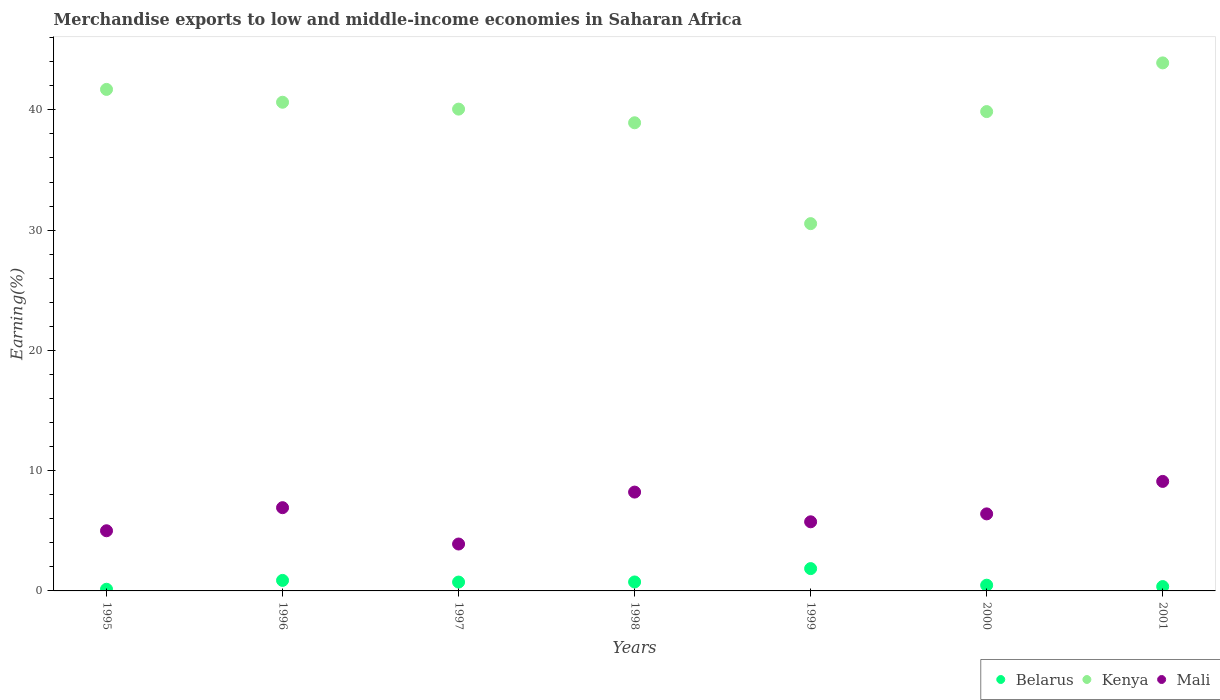How many different coloured dotlines are there?
Provide a short and direct response. 3. Is the number of dotlines equal to the number of legend labels?
Ensure brevity in your answer.  Yes. What is the percentage of amount earned from merchandise exports in Belarus in 1996?
Ensure brevity in your answer.  0.87. Across all years, what is the maximum percentage of amount earned from merchandise exports in Belarus?
Provide a succinct answer. 1.86. Across all years, what is the minimum percentage of amount earned from merchandise exports in Kenya?
Offer a terse response. 30.54. What is the total percentage of amount earned from merchandise exports in Belarus in the graph?
Make the answer very short. 5.19. What is the difference between the percentage of amount earned from merchandise exports in Mali in 1998 and that in 1999?
Make the answer very short. 2.47. What is the difference between the percentage of amount earned from merchandise exports in Mali in 1997 and the percentage of amount earned from merchandise exports in Belarus in 1996?
Offer a very short reply. 3.03. What is the average percentage of amount earned from merchandise exports in Belarus per year?
Make the answer very short. 0.74. In the year 2001, what is the difference between the percentage of amount earned from merchandise exports in Kenya and percentage of amount earned from merchandise exports in Belarus?
Provide a succinct answer. 43.54. In how many years, is the percentage of amount earned from merchandise exports in Kenya greater than 26 %?
Your answer should be compact. 7. What is the ratio of the percentage of amount earned from merchandise exports in Belarus in 1996 to that in 1998?
Your answer should be very brief. 1.17. What is the difference between the highest and the second highest percentage of amount earned from merchandise exports in Mali?
Your answer should be compact. 0.89. What is the difference between the highest and the lowest percentage of amount earned from merchandise exports in Kenya?
Ensure brevity in your answer.  13.37. Is the sum of the percentage of amount earned from merchandise exports in Mali in 1995 and 2001 greater than the maximum percentage of amount earned from merchandise exports in Kenya across all years?
Your answer should be very brief. No. Is it the case that in every year, the sum of the percentage of amount earned from merchandise exports in Belarus and percentage of amount earned from merchandise exports in Mali  is greater than the percentage of amount earned from merchandise exports in Kenya?
Offer a very short reply. No. Does the percentage of amount earned from merchandise exports in Kenya monotonically increase over the years?
Provide a succinct answer. No. Is the percentage of amount earned from merchandise exports in Mali strictly less than the percentage of amount earned from merchandise exports in Belarus over the years?
Your response must be concise. No. How many years are there in the graph?
Offer a very short reply. 7. What is the difference between two consecutive major ticks on the Y-axis?
Offer a very short reply. 10. Does the graph contain grids?
Provide a short and direct response. No. What is the title of the graph?
Your answer should be compact. Merchandise exports to low and middle-income economies in Saharan Africa. What is the label or title of the Y-axis?
Your answer should be very brief. Earning(%). What is the Earning(%) of Belarus in 1995?
Ensure brevity in your answer.  0.14. What is the Earning(%) in Kenya in 1995?
Ensure brevity in your answer.  41.7. What is the Earning(%) in Mali in 1995?
Your answer should be very brief. 5. What is the Earning(%) of Belarus in 1996?
Your answer should be compact. 0.87. What is the Earning(%) of Kenya in 1996?
Provide a succinct answer. 40.63. What is the Earning(%) in Mali in 1996?
Give a very brief answer. 6.92. What is the Earning(%) in Belarus in 1997?
Offer a terse response. 0.74. What is the Earning(%) of Kenya in 1997?
Provide a succinct answer. 40.06. What is the Earning(%) of Mali in 1997?
Your answer should be compact. 3.9. What is the Earning(%) of Belarus in 1998?
Offer a very short reply. 0.74. What is the Earning(%) of Kenya in 1998?
Keep it short and to the point. 38.92. What is the Earning(%) in Mali in 1998?
Keep it short and to the point. 8.22. What is the Earning(%) of Belarus in 1999?
Ensure brevity in your answer.  1.86. What is the Earning(%) in Kenya in 1999?
Your answer should be compact. 30.54. What is the Earning(%) in Mali in 1999?
Your response must be concise. 5.75. What is the Earning(%) of Belarus in 2000?
Provide a short and direct response. 0.48. What is the Earning(%) of Kenya in 2000?
Offer a terse response. 39.85. What is the Earning(%) in Mali in 2000?
Your response must be concise. 6.41. What is the Earning(%) of Belarus in 2001?
Keep it short and to the point. 0.36. What is the Earning(%) of Kenya in 2001?
Give a very brief answer. 43.9. What is the Earning(%) of Mali in 2001?
Make the answer very short. 9.11. Across all years, what is the maximum Earning(%) of Belarus?
Your response must be concise. 1.86. Across all years, what is the maximum Earning(%) in Kenya?
Offer a very short reply. 43.9. Across all years, what is the maximum Earning(%) in Mali?
Offer a very short reply. 9.11. Across all years, what is the minimum Earning(%) in Belarus?
Provide a succinct answer. 0.14. Across all years, what is the minimum Earning(%) in Kenya?
Give a very brief answer. 30.54. Across all years, what is the minimum Earning(%) in Mali?
Make the answer very short. 3.9. What is the total Earning(%) in Belarus in the graph?
Offer a terse response. 5.19. What is the total Earning(%) of Kenya in the graph?
Ensure brevity in your answer.  275.61. What is the total Earning(%) of Mali in the graph?
Offer a terse response. 45.3. What is the difference between the Earning(%) in Belarus in 1995 and that in 1996?
Offer a terse response. -0.74. What is the difference between the Earning(%) in Kenya in 1995 and that in 1996?
Make the answer very short. 1.07. What is the difference between the Earning(%) in Mali in 1995 and that in 1996?
Make the answer very short. -1.92. What is the difference between the Earning(%) in Belarus in 1995 and that in 1997?
Your response must be concise. -0.6. What is the difference between the Earning(%) in Kenya in 1995 and that in 1997?
Provide a short and direct response. 1.64. What is the difference between the Earning(%) of Mali in 1995 and that in 1997?
Provide a succinct answer. 1.1. What is the difference between the Earning(%) in Belarus in 1995 and that in 1998?
Make the answer very short. -0.61. What is the difference between the Earning(%) of Kenya in 1995 and that in 1998?
Ensure brevity in your answer.  2.77. What is the difference between the Earning(%) in Mali in 1995 and that in 1998?
Offer a terse response. -3.21. What is the difference between the Earning(%) of Belarus in 1995 and that in 1999?
Your response must be concise. -1.72. What is the difference between the Earning(%) of Kenya in 1995 and that in 1999?
Keep it short and to the point. 11.16. What is the difference between the Earning(%) in Mali in 1995 and that in 1999?
Your answer should be very brief. -0.74. What is the difference between the Earning(%) of Belarus in 1995 and that in 2000?
Give a very brief answer. -0.34. What is the difference between the Earning(%) in Kenya in 1995 and that in 2000?
Give a very brief answer. 1.84. What is the difference between the Earning(%) in Mali in 1995 and that in 2000?
Your answer should be compact. -1.4. What is the difference between the Earning(%) in Belarus in 1995 and that in 2001?
Ensure brevity in your answer.  -0.22. What is the difference between the Earning(%) of Kenya in 1995 and that in 2001?
Your answer should be compact. -2.2. What is the difference between the Earning(%) of Mali in 1995 and that in 2001?
Offer a very short reply. -4.1. What is the difference between the Earning(%) in Belarus in 1996 and that in 1997?
Your answer should be very brief. 0.14. What is the difference between the Earning(%) of Mali in 1996 and that in 1997?
Give a very brief answer. 3.02. What is the difference between the Earning(%) of Belarus in 1996 and that in 1998?
Provide a short and direct response. 0.13. What is the difference between the Earning(%) in Kenya in 1996 and that in 1998?
Ensure brevity in your answer.  1.71. What is the difference between the Earning(%) of Mali in 1996 and that in 1998?
Give a very brief answer. -1.3. What is the difference between the Earning(%) of Belarus in 1996 and that in 1999?
Provide a short and direct response. -0.98. What is the difference between the Earning(%) in Kenya in 1996 and that in 1999?
Give a very brief answer. 10.09. What is the difference between the Earning(%) of Mali in 1996 and that in 1999?
Provide a succinct answer. 1.17. What is the difference between the Earning(%) of Belarus in 1996 and that in 2000?
Ensure brevity in your answer.  0.4. What is the difference between the Earning(%) in Kenya in 1996 and that in 2000?
Your answer should be compact. 0.78. What is the difference between the Earning(%) in Mali in 1996 and that in 2000?
Your answer should be compact. 0.52. What is the difference between the Earning(%) of Belarus in 1996 and that in 2001?
Your response must be concise. 0.51. What is the difference between the Earning(%) of Kenya in 1996 and that in 2001?
Your response must be concise. -3.27. What is the difference between the Earning(%) of Mali in 1996 and that in 2001?
Offer a very short reply. -2.18. What is the difference between the Earning(%) of Belarus in 1997 and that in 1998?
Provide a succinct answer. -0.01. What is the difference between the Earning(%) in Kenya in 1997 and that in 1998?
Your answer should be compact. 1.14. What is the difference between the Earning(%) in Mali in 1997 and that in 1998?
Your response must be concise. -4.32. What is the difference between the Earning(%) in Belarus in 1997 and that in 1999?
Make the answer very short. -1.12. What is the difference between the Earning(%) of Kenya in 1997 and that in 1999?
Offer a terse response. 9.52. What is the difference between the Earning(%) of Mali in 1997 and that in 1999?
Your response must be concise. -1.85. What is the difference between the Earning(%) in Belarus in 1997 and that in 2000?
Your response must be concise. 0.26. What is the difference between the Earning(%) in Kenya in 1997 and that in 2000?
Make the answer very short. 0.21. What is the difference between the Earning(%) of Mali in 1997 and that in 2000?
Offer a terse response. -2.51. What is the difference between the Earning(%) in Belarus in 1997 and that in 2001?
Your answer should be very brief. 0.37. What is the difference between the Earning(%) of Kenya in 1997 and that in 2001?
Keep it short and to the point. -3.84. What is the difference between the Earning(%) in Mali in 1997 and that in 2001?
Keep it short and to the point. -5.21. What is the difference between the Earning(%) of Belarus in 1998 and that in 1999?
Your response must be concise. -1.11. What is the difference between the Earning(%) of Kenya in 1998 and that in 1999?
Your response must be concise. 8.39. What is the difference between the Earning(%) in Mali in 1998 and that in 1999?
Keep it short and to the point. 2.47. What is the difference between the Earning(%) in Belarus in 1998 and that in 2000?
Keep it short and to the point. 0.27. What is the difference between the Earning(%) in Kenya in 1998 and that in 2000?
Give a very brief answer. -0.93. What is the difference between the Earning(%) of Mali in 1998 and that in 2000?
Keep it short and to the point. 1.81. What is the difference between the Earning(%) in Belarus in 1998 and that in 2001?
Make the answer very short. 0.38. What is the difference between the Earning(%) in Kenya in 1998 and that in 2001?
Give a very brief answer. -4.98. What is the difference between the Earning(%) of Mali in 1998 and that in 2001?
Keep it short and to the point. -0.89. What is the difference between the Earning(%) of Belarus in 1999 and that in 2000?
Give a very brief answer. 1.38. What is the difference between the Earning(%) in Kenya in 1999 and that in 2000?
Give a very brief answer. -9.32. What is the difference between the Earning(%) of Mali in 1999 and that in 2000?
Provide a succinct answer. -0.66. What is the difference between the Earning(%) in Belarus in 1999 and that in 2001?
Your response must be concise. 1.49. What is the difference between the Earning(%) in Kenya in 1999 and that in 2001?
Give a very brief answer. -13.37. What is the difference between the Earning(%) of Mali in 1999 and that in 2001?
Your answer should be very brief. -3.36. What is the difference between the Earning(%) in Belarus in 2000 and that in 2001?
Provide a succinct answer. 0.11. What is the difference between the Earning(%) in Kenya in 2000 and that in 2001?
Provide a succinct answer. -4.05. What is the difference between the Earning(%) in Mali in 2000 and that in 2001?
Keep it short and to the point. -2.7. What is the difference between the Earning(%) of Belarus in 1995 and the Earning(%) of Kenya in 1996?
Offer a very short reply. -40.49. What is the difference between the Earning(%) of Belarus in 1995 and the Earning(%) of Mali in 1996?
Offer a terse response. -6.78. What is the difference between the Earning(%) in Kenya in 1995 and the Earning(%) in Mali in 1996?
Provide a succinct answer. 34.78. What is the difference between the Earning(%) of Belarus in 1995 and the Earning(%) of Kenya in 1997?
Ensure brevity in your answer.  -39.92. What is the difference between the Earning(%) of Belarus in 1995 and the Earning(%) of Mali in 1997?
Provide a succinct answer. -3.76. What is the difference between the Earning(%) of Kenya in 1995 and the Earning(%) of Mali in 1997?
Ensure brevity in your answer.  37.8. What is the difference between the Earning(%) of Belarus in 1995 and the Earning(%) of Kenya in 1998?
Offer a terse response. -38.79. What is the difference between the Earning(%) in Belarus in 1995 and the Earning(%) in Mali in 1998?
Ensure brevity in your answer.  -8.08. What is the difference between the Earning(%) in Kenya in 1995 and the Earning(%) in Mali in 1998?
Make the answer very short. 33.48. What is the difference between the Earning(%) of Belarus in 1995 and the Earning(%) of Kenya in 1999?
Ensure brevity in your answer.  -30.4. What is the difference between the Earning(%) in Belarus in 1995 and the Earning(%) in Mali in 1999?
Provide a short and direct response. -5.61. What is the difference between the Earning(%) of Kenya in 1995 and the Earning(%) of Mali in 1999?
Offer a very short reply. 35.95. What is the difference between the Earning(%) in Belarus in 1995 and the Earning(%) in Kenya in 2000?
Offer a very short reply. -39.72. What is the difference between the Earning(%) in Belarus in 1995 and the Earning(%) in Mali in 2000?
Provide a succinct answer. -6.27. What is the difference between the Earning(%) of Kenya in 1995 and the Earning(%) of Mali in 2000?
Provide a short and direct response. 35.29. What is the difference between the Earning(%) of Belarus in 1995 and the Earning(%) of Kenya in 2001?
Make the answer very short. -43.76. What is the difference between the Earning(%) in Belarus in 1995 and the Earning(%) in Mali in 2001?
Offer a very short reply. -8.97. What is the difference between the Earning(%) of Kenya in 1995 and the Earning(%) of Mali in 2001?
Give a very brief answer. 32.59. What is the difference between the Earning(%) in Belarus in 1996 and the Earning(%) in Kenya in 1997?
Keep it short and to the point. -39.19. What is the difference between the Earning(%) of Belarus in 1996 and the Earning(%) of Mali in 1997?
Your answer should be very brief. -3.03. What is the difference between the Earning(%) in Kenya in 1996 and the Earning(%) in Mali in 1997?
Give a very brief answer. 36.73. What is the difference between the Earning(%) in Belarus in 1996 and the Earning(%) in Kenya in 1998?
Make the answer very short. -38.05. What is the difference between the Earning(%) of Belarus in 1996 and the Earning(%) of Mali in 1998?
Offer a terse response. -7.34. What is the difference between the Earning(%) of Kenya in 1996 and the Earning(%) of Mali in 1998?
Ensure brevity in your answer.  32.41. What is the difference between the Earning(%) in Belarus in 1996 and the Earning(%) in Kenya in 1999?
Your response must be concise. -29.66. What is the difference between the Earning(%) of Belarus in 1996 and the Earning(%) of Mali in 1999?
Your response must be concise. -4.87. What is the difference between the Earning(%) of Kenya in 1996 and the Earning(%) of Mali in 1999?
Offer a very short reply. 34.88. What is the difference between the Earning(%) in Belarus in 1996 and the Earning(%) in Kenya in 2000?
Your answer should be compact. -38.98. What is the difference between the Earning(%) of Belarus in 1996 and the Earning(%) of Mali in 2000?
Offer a terse response. -5.53. What is the difference between the Earning(%) of Kenya in 1996 and the Earning(%) of Mali in 2000?
Offer a terse response. 34.23. What is the difference between the Earning(%) of Belarus in 1996 and the Earning(%) of Kenya in 2001?
Your answer should be very brief. -43.03. What is the difference between the Earning(%) in Belarus in 1996 and the Earning(%) in Mali in 2001?
Offer a terse response. -8.23. What is the difference between the Earning(%) in Kenya in 1996 and the Earning(%) in Mali in 2001?
Ensure brevity in your answer.  31.53. What is the difference between the Earning(%) in Belarus in 1997 and the Earning(%) in Kenya in 1998?
Your response must be concise. -38.19. What is the difference between the Earning(%) in Belarus in 1997 and the Earning(%) in Mali in 1998?
Your response must be concise. -7.48. What is the difference between the Earning(%) of Kenya in 1997 and the Earning(%) of Mali in 1998?
Your answer should be very brief. 31.84. What is the difference between the Earning(%) in Belarus in 1997 and the Earning(%) in Kenya in 1999?
Make the answer very short. -29.8. What is the difference between the Earning(%) of Belarus in 1997 and the Earning(%) of Mali in 1999?
Your response must be concise. -5.01. What is the difference between the Earning(%) of Kenya in 1997 and the Earning(%) of Mali in 1999?
Provide a succinct answer. 34.31. What is the difference between the Earning(%) in Belarus in 1997 and the Earning(%) in Kenya in 2000?
Offer a terse response. -39.12. What is the difference between the Earning(%) in Belarus in 1997 and the Earning(%) in Mali in 2000?
Your answer should be very brief. -5.67. What is the difference between the Earning(%) in Kenya in 1997 and the Earning(%) in Mali in 2000?
Give a very brief answer. 33.65. What is the difference between the Earning(%) in Belarus in 1997 and the Earning(%) in Kenya in 2001?
Offer a very short reply. -43.17. What is the difference between the Earning(%) in Belarus in 1997 and the Earning(%) in Mali in 2001?
Offer a terse response. -8.37. What is the difference between the Earning(%) of Kenya in 1997 and the Earning(%) of Mali in 2001?
Give a very brief answer. 30.96. What is the difference between the Earning(%) in Belarus in 1998 and the Earning(%) in Kenya in 1999?
Provide a succinct answer. -29.79. What is the difference between the Earning(%) in Belarus in 1998 and the Earning(%) in Mali in 1999?
Offer a very short reply. -5. What is the difference between the Earning(%) in Kenya in 1998 and the Earning(%) in Mali in 1999?
Offer a terse response. 33.18. What is the difference between the Earning(%) of Belarus in 1998 and the Earning(%) of Kenya in 2000?
Your answer should be compact. -39.11. What is the difference between the Earning(%) of Belarus in 1998 and the Earning(%) of Mali in 2000?
Your answer should be very brief. -5.66. What is the difference between the Earning(%) in Kenya in 1998 and the Earning(%) in Mali in 2000?
Give a very brief answer. 32.52. What is the difference between the Earning(%) of Belarus in 1998 and the Earning(%) of Kenya in 2001?
Keep it short and to the point. -43.16. What is the difference between the Earning(%) of Belarus in 1998 and the Earning(%) of Mali in 2001?
Provide a succinct answer. -8.36. What is the difference between the Earning(%) of Kenya in 1998 and the Earning(%) of Mali in 2001?
Ensure brevity in your answer.  29.82. What is the difference between the Earning(%) of Belarus in 1999 and the Earning(%) of Kenya in 2000?
Provide a short and direct response. -38. What is the difference between the Earning(%) of Belarus in 1999 and the Earning(%) of Mali in 2000?
Offer a very short reply. -4.55. What is the difference between the Earning(%) in Kenya in 1999 and the Earning(%) in Mali in 2000?
Give a very brief answer. 24.13. What is the difference between the Earning(%) in Belarus in 1999 and the Earning(%) in Kenya in 2001?
Offer a terse response. -42.05. What is the difference between the Earning(%) of Belarus in 1999 and the Earning(%) of Mali in 2001?
Offer a very short reply. -7.25. What is the difference between the Earning(%) of Kenya in 1999 and the Earning(%) of Mali in 2001?
Your answer should be compact. 21.43. What is the difference between the Earning(%) in Belarus in 2000 and the Earning(%) in Kenya in 2001?
Provide a short and direct response. -43.43. What is the difference between the Earning(%) of Belarus in 2000 and the Earning(%) of Mali in 2001?
Provide a short and direct response. -8.63. What is the difference between the Earning(%) in Kenya in 2000 and the Earning(%) in Mali in 2001?
Provide a short and direct response. 30.75. What is the average Earning(%) in Belarus per year?
Offer a very short reply. 0.74. What is the average Earning(%) in Kenya per year?
Provide a short and direct response. 39.37. What is the average Earning(%) of Mali per year?
Your response must be concise. 6.47. In the year 1995, what is the difference between the Earning(%) in Belarus and Earning(%) in Kenya?
Give a very brief answer. -41.56. In the year 1995, what is the difference between the Earning(%) in Belarus and Earning(%) in Mali?
Offer a terse response. -4.86. In the year 1995, what is the difference between the Earning(%) in Kenya and Earning(%) in Mali?
Your answer should be compact. 36.7. In the year 1996, what is the difference between the Earning(%) of Belarus and Earning(%) of Kenya?
Your answer should be very brief. -39.76. In the year 1996, what is the difference between the Earning(%) of Belarus and Earning(%) of Mali?
Keep it short and to the point. -6.05. In the year 1996, what is the difference between the Earning(%) of Kenya and Earning(%) of Mali?
Give a very brief answer. 33.71. In the year 1997, what is the difference between the Earning(%) of Belarus and Earning(%) of Kenya?
Make the answer very short. -39.32. In the year 1997, what is the difference between the Earning(%) of Belarus and Earning(%) of Mali?
Give a very brief answer. -3.16. In the year 1997, what is the difference between the Earning(%) in Kenya and Earning(%) in Mali?
Offer a terse response. 36.16. In the year 1998, what is the difference between the Earning(%) in Belarus and Earning(%) in Kenya?
Offer a very short reply. -38.18. In the year 1998, what is the difference between the Earning(%) of Belarus and Earning(%) of Mali?
Your response must be concise. -7.47. In the year 1998, what is the difference between the Earning(%) of Kenya and Earning(%) of Mali?
Give a very brief answer. 30.71. In the year 1999, what is the difference between the Earning(%) in Belarus and Earning(%) in Kenya?
Offer a terse response. -28.68. In the year 1999, what is the difference between the Earning(%) in Belarus and Earning(%) in Mali?
Make the answer very short. -3.89. In the year 1999, what is the difference between the Earning(%) in Kenya and Earning(%) in Mali?
Offer a terse response. 24.79. In the year 2000, what is the difference between the Earning(%) in Belarus and Earning(%) in Kenya?
Offer a terse response. -39.38. In the year 2000, what is the difference between the Earning(%) in Belarus and Earning(%) in Mali?
Offer a terse response. -5.93. In the year 2000, what is the difference between the Earning(%) of Kenya and Earning(%) of Mali?
Keep it short and to the point. 33.45. In the year 2001, what is the difference between the Earning(%) of Belarus and Earning(%) of Kenya?
Offer a terse response. -43.54. In the year 2001, what is the difference between the Earning(%) of Belarus and Earning(%) of Mali?
Offer a terse response. -8.74. In the year 2001, what is the difference between the Earning(%) of Kenya and Earning(%) of Mali?
Your answer should be very brief. 34.8. What is the ratio of the Earning(%) in Belarus in 1995 to that in 1996?
Offer a very short reply. 0.16. What is the ratio of the Earning(%) of Kenya in 1995 to that in 1996?
Provide a succinct answer. 1.03. What is the ratio of the Earning(%) in Mali in 1995 to that in 1996?
Your answer should be compact. 0.72. What is the ratio of the Earning(%) of Belarus in 1995 to that in 1997?
Keep it short and to the point. 0.19. What is the ratio of the Earning(%) in Kenya in 1995 to that in 1997?
Your answer should be very brief. 1.04. What is the ratio of the Earning(%) in Mali in 1995 to that in 1997?
Provide a succinct answer. 1.28. What is the ratio of the Earning(%) of Belarus in 1995 to that in 1998?
Provide a short and direct response. 0.19. What is the ratio of the Earning(%) in Kenya in 1995 to that in 1998?
Give a very brief answer. 1.07. What is the ratio of the Earning(%) of Mali in 1995 to that in 1998?
Your answer should be compact. 0.61. What is the ratio of the Earning(%) in Belarus in 1995 to that in 1999?
Provide a succinct answer. 0.07. What is the ratio of the Earning(%) in Kenya in 1995 to that in 1999?
Keep it short and to the point. 1.37. What is the ratio of the Earning(%) in Mali in 1995 to that in 1999?
Keep it short and to the point. 0.87. What is the ratio of the Earning(%) of Belarus in 1995 to that in 2000?
Provide a succinct answer. 0.29. What is the ratio of the Earning(%) of Kenya in 1995 to that in 2000?
Keep it short and to the point. 1.05. What is the ratio of the Earning(%) in Mali in 1995 to that in 2000?
Your answer should be compact. 0.78. What is the ratio of the Earning(%) in Belarus in 1995 to that in 2001?
Your answer should be very brief. 0.38. What is the ratio of the Earning(%) in Kenya in 1995 to that in 2001?
Offer a very short reply. 0.95. What is the ratio of the Earning(%) of Mali in 1995 to that in 2001?
Offer a very short reply. 0.55. What is the ratio of the Earning(%) in Belarus in 1996 to that in 1997?
Offer a terse response. 1.19. What is the ratio of the Earning(%) of Kenya in 1996 to that in 1997?
Offer a very short reply. 1.01. What is the ratio of the Earning(%) of Mali in 1996 to that in 1997?
Offer a very short reply. 1.77. What is the ratio of the Earning(%) of Belarus in 1996 to that in 1998?
Give a very brief answer. 1.17. What is the ratio of the Earning(%) of Kenya in 1996 to that in 1998?
Offer a very short reply. 1.04. What is the ratio of the Earning(%) in Mali in 1996 to that in 1998?
Offer a very short reply. 0.84. What is the ratio of the Earning(%) in Belarus in 1996 to that in 1999?
Provide a succinct answer. 0.47. What is the ratio of the Earning(%) of Kenya in 1996 to that in 1999?
Your answer should be compact. 1.33. What is the ratio of the Earning(%) in Mali in 1996 to that in 1999?
Your response must be concise. 1.2. What is the ratio of the Earning(%) in Belarus in 1996 to that in 2000?
Your answer should be compact. 1.84. What is the ratio of the Earning(%) of Kenya in 1996 to that in 2000?
Offer a very short reply. 1.02. What is the ratio of the Earning(%) in Mali in 1996 to that in 2000?
Offer a very short reply. 1.08. What is the ratio of the Earning(%) of Belarus in 1996 to that in 2001?
Make the answer very short. 2.42. What is the ratio of the Earning(%) in Kenya in 1996 to that in 2001?
Give a very brief answer. 0.93. What is the ratio of the Earning(%) of Mali in 1996 to that in 2001?
Your answer should be compact. 0.76. What is the ratio of the Earning(%) of Kenya in 1997 to that in 1998?
Offer a very short reply. 1.03. What is the ratio of the Earning(%) in Mali in 1997 to that in 1998?
Offer a terse response. 0.47. What is the ratio of the Earning(%) in Belarus in 1997 to that in 1999?
Offer a terse response. 0.4. What is the ratio of the Earning(%) of Kenya in 1997 to that in 1999?
Offer a terse response. 1.31. What is the ratio of the Earning(%) in Mali in 1997 to that in 1999?
Offer a very short reply. 0.68. What is the ratio of the Earning(%) of Belarus in 1997 to that in 2000?
Give a very brief answer. 1.55. What is the ratio of the Earning(%) of Kenya in 1997 to that in 2000?
Make the answer very short. 1.01. What is the ratio of the Earning(%) of Mali in 1997 to that in 2000?
Provide a short and direct response. 0.61. What is the ratio of the Earning(%) of Belarus in 1997 to that in 2001?
Your answer should be compact. 2.03. What is the ratio of the Earning(%) of Kenya in 1997 to that in 2001?
Your answer should be very brief. 0.91. What is the ratio of the Earning(%) of Mali in 1997 to that in 2001?
Make the answer very short. 0.43. What is the ratio of the Earning(%) in Belarus in 1998 to that in 1999?
Provide a short and direct response. 0.4. What is the ratio of the Earning(%) of Kenya in 1998 to that in 1999?
Provide a succinct answer. 1.27. What is the ratio of the Earning(%) of Mali in 1998 to that in 1999?
Provide a short and direct response. 1.43. What is the ratio of the Earning(%) of Belarus in 1998 to that in 2000?
Keep it short and to the point. 1.57. What is the ratio of the Earning(%) in Kenya in 1998 to that in 2000?
Your answer should be compact. 0.98. What is the ratio of the Earning(%) in Mali in 1998 to that in 2000?
Your answer should be compact. 1.28. What is the ratio of the Earning(%) in Belarus in 1998 to that in 2001?
Provide a short and direct response. 2.06. What is the ratio of the Earning(%) in Kenya in 1998 to that in 2001?
Your answer should be compact. 0.89. What is the ratio of the Earning(%) in Mali in 1998 to that in 2001?
Offer a terse response. 0.9. What is the ratio of the Earning(%) in Belarus in 1999 to that in 2000?
Your answer should be very brief. 3.9. What is the ratio of the Earning(%) of Kenya in 1999 to that in 2000?
Give a very brief answer. 0.77. What is the ratio of the Earning(%) in Mali in 1999 to that in 2000?
Provide a succinct answer. 0.9. What is the ratio of the Earning(%) in Belarus in 1999 to that in 2001?
Ensure brevity in your answer.  5.13. What is the ratio of the Earning(%) of Kenya in 1999 to that in 2001?
Keep it short and to the point. 0.7. What is the ratio of the Earning(%) in Mali in 1999 to that in 2001?
Your answer should be compact. 0.63. What is the ratio of the Earning(%) of Belarus in 2000 to that in 2001?
Give a very brief answer. 1.31. What is the ratio of the Earning(%) in Kenya in 2000 to that in 2001?
Offer a very short reply. 0.91. What is the ratio of the Earning(%) in Mali in 2000 to that in 2001?
Your answer should be compact. 0.7. What is the difference between the highest and the second highest Earning(%) in Belarus?
Your answer should be very brief. 0.98. What is the difference between the highest and the second highest Earning(%) in Kenya?
Offer a very short reply. 2.2. What is the difference between the highest and the second highest Earning(%) in Mali?
Offer a very short reply. 0.89. What is the difference between the highest and the lowest Earning(%) in Belarus?
Make the answer very short. 1.72. What is the difference between the highest and the lowest Earning(%) in Kenya?
Make the answer very short. 13.37. What is the difference between the highest and the lowest Earning(%) of Mali?
Give a very brief answer. 5.21. 